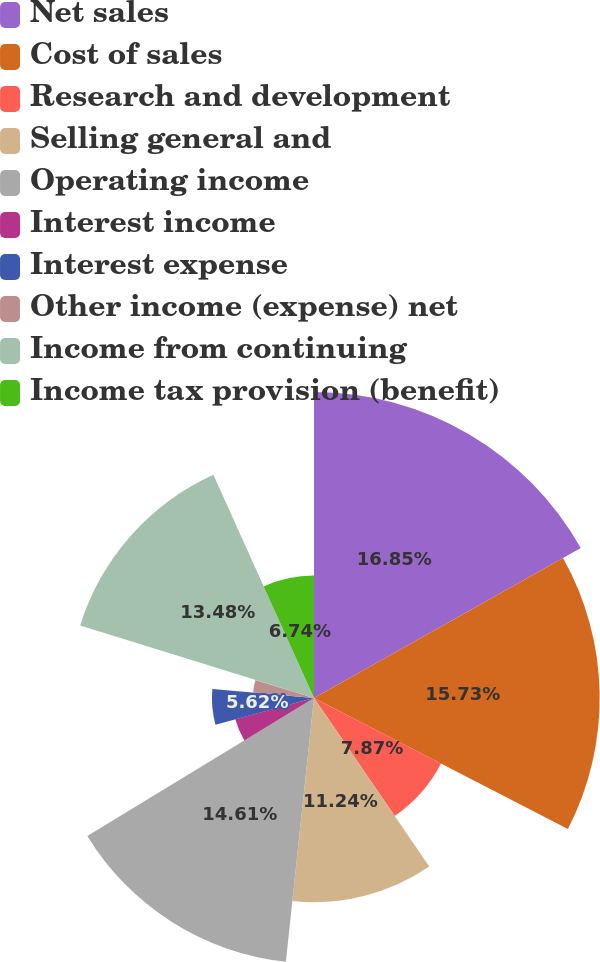Convert chart to OTSL. <chart><loc_0><loc_0><loc_500><loc_500><pie_chart><fcel>Net sales<fcel>Cost of sales<fcel>Research and development<fcel>Selling general and<fcel>Operating income<fcel>Interest income<fcel>Interest expense<fcel>Other income (expense) net<fcel>Income from continuing<fcel>Income tax provision (benefit)<nl><fcel>16.85%<fcel>15.73%<fcel>7.87%<fcel>11.24%<fcel>14.61%<fcel>4.49%<fcel>5.62%<fcel>3.37%<fcel>13.48%<fcel>6.74%<nl></chart> 